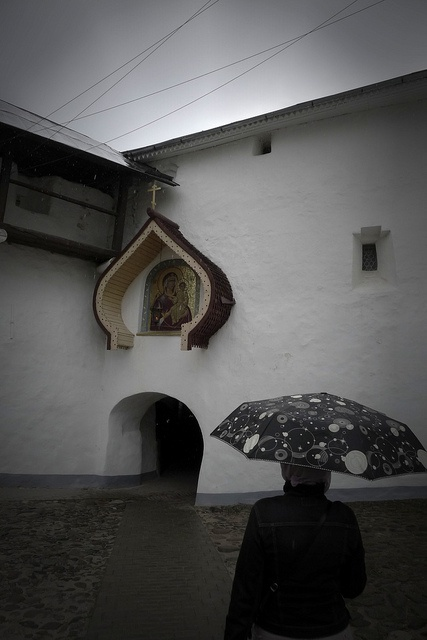Describe the objects in this image and their specific colors. I can see people in black and gray tones and umbrella in black, gray, and darkgray tones in this image. 